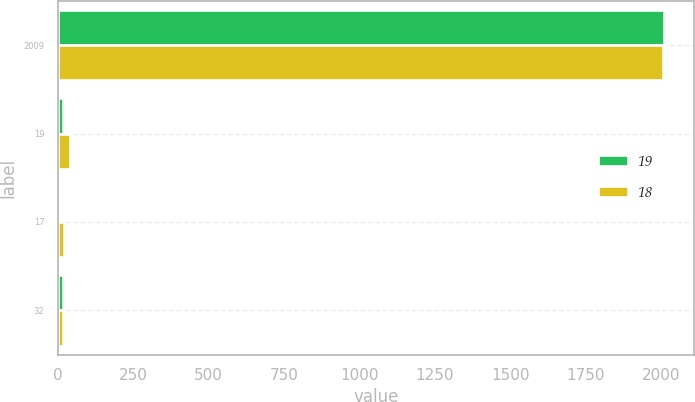Convert chart to OTSL. <chart><loc_0><loc_0><loc_500><loc_500><stacked_bar_chart><ecel><fcel>2009<fcel>19<fcel>17<fcel>32<nl><fcel>19<fcel>2008<fcel>18<fcel>1<fcel>19<nl><fcel>18<fcel>2007<fcel>40<fcel>22<fcel>18<nl></chart> 